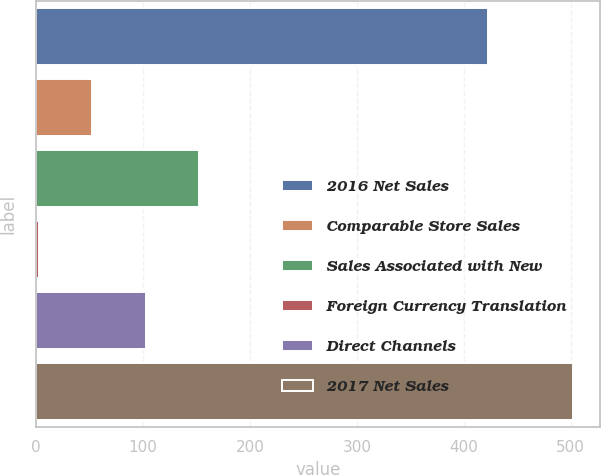Convert chart. <chart><loc_0><loc_0><loc_500><loc_500><bar_chart><fcel>2016 Net Sales<fcel>Comparable Store Sales<fcel>Sales Associated with New<fcel>Foreign Currency Translation<fcel>Direct Channels<fcel>2017 Net Sales<nl><fcel>423<fcel>52.9<fcel>152.7<fcel>3<fcel>102.8<fcel>502<nl></chart> 